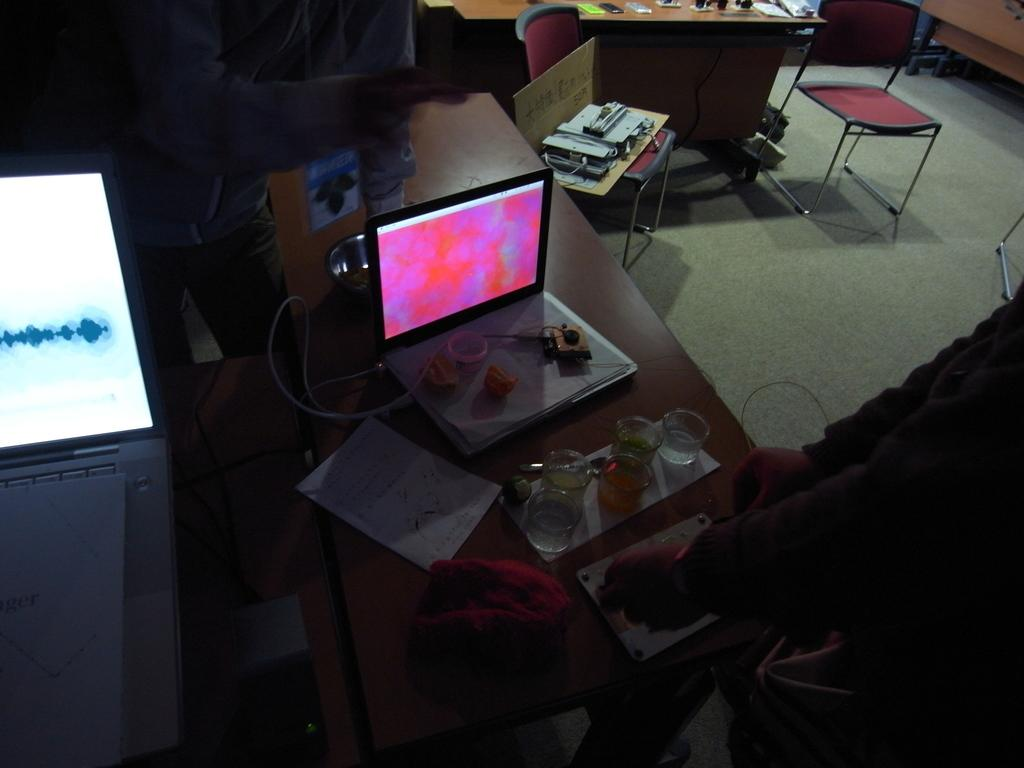What electronic device is visible in the image? There is a laptop in the image. What items are used for vision enhancement in the image? There are glasses in the image. What writing instruments are present in the image? There are pens in the image. Where are the objects located in the image? The objects are on a table. How many people are in the room in the image? There are two persons standing in the room. What type of rice is being cooked in the image? There is no rice present in the image; it only features a laptop, glasses, pens, a table, and two persons standing in the room. 